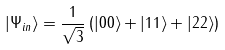<formula> <loc_0><loc_0><loc_500><loc_500>| \Psi _ { i n } \rangle = \frac { 1 } { \sqrt { 3 } } \left ( | 0 0 \rangle + | 1 1 \rangle + | 2 2 \rangle \right )</formula> 